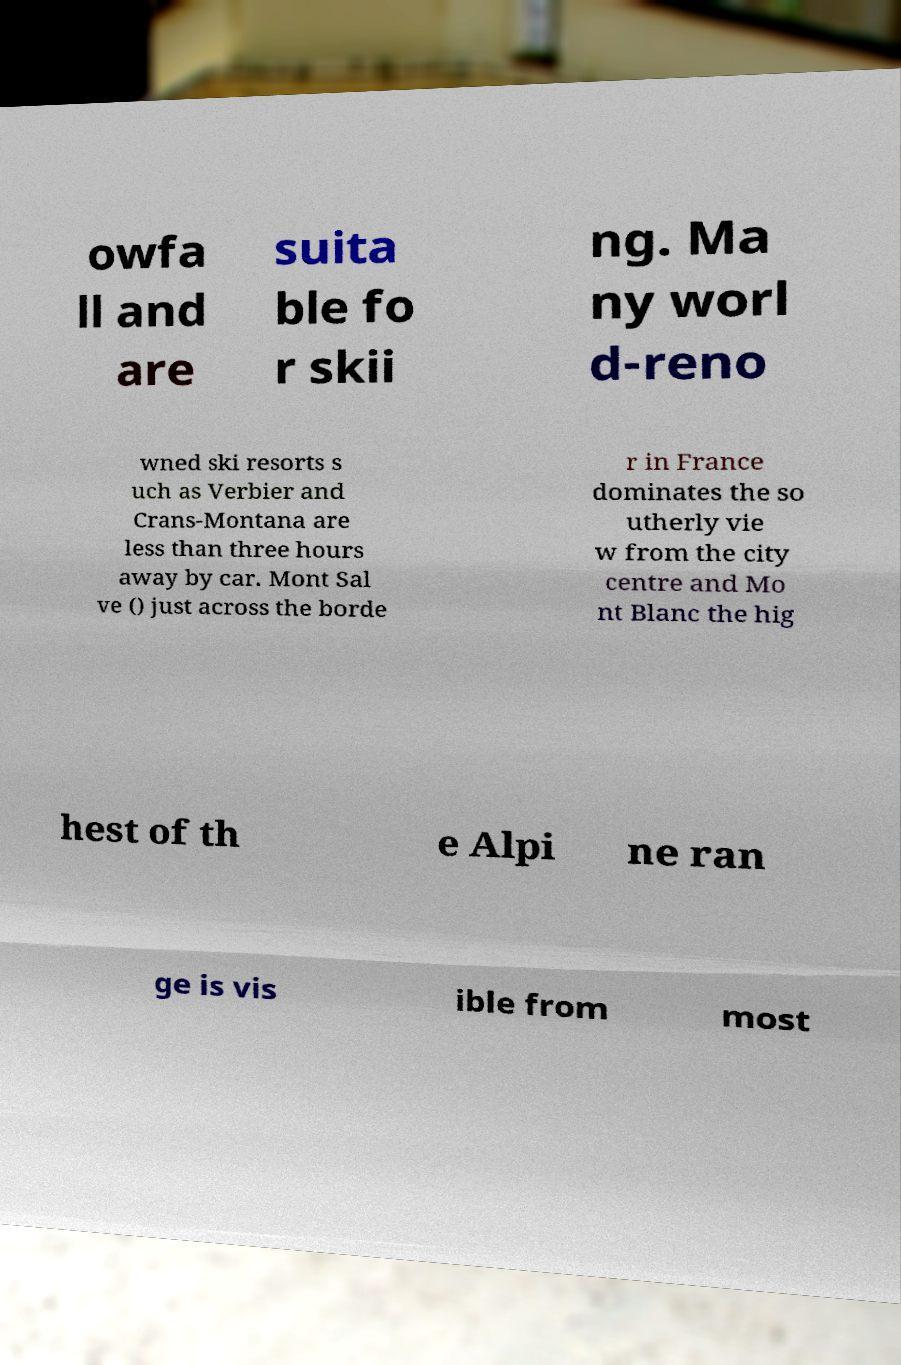I need the written content from this picture converted into text. Can you do that? owfa ll and are suita ble fo r skii ng. Ma ny worl d-reno wned ski resorts s uch as Verbier and Crans-Montana are less than three hours away by car. Mont Sal ve () just across the borde r in France dominates the so utherly vie w from the city centre and Mo nt Blanc the hig hest of th e Alpi ne ran ge is vis ible from most 